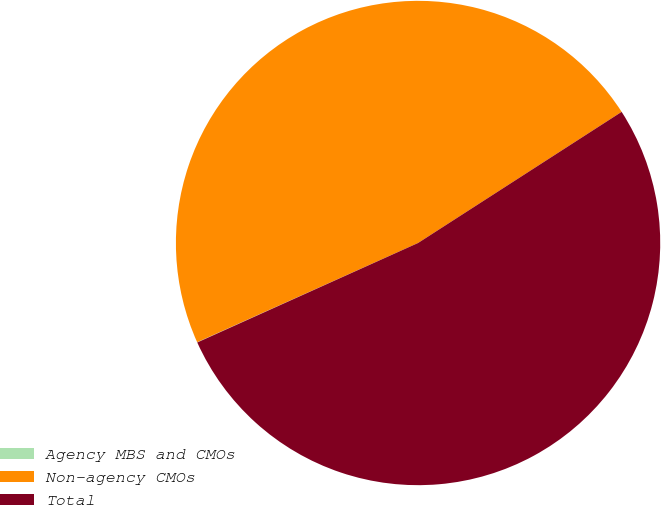Convert chart to OTSL. <chart><loc_0><loc_0><loc_500><loc_500><pie_chart><fcel>Agency MBS and CMOs<fcel>Non-agency CMOs<fcel>Total<nl><fcel>0.02%<fcel>47.61%<fcel>52.37%<nl></chart> 